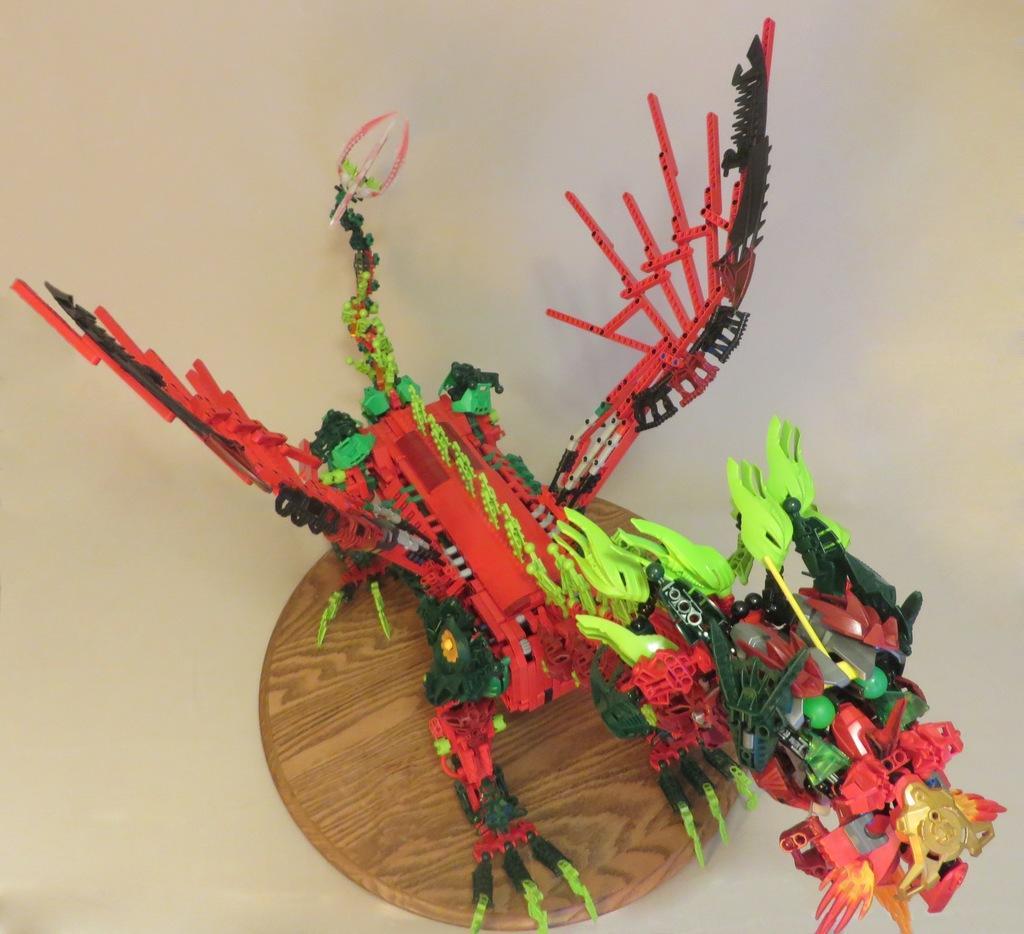Please provide a concise description of this image. On this wooden platter there is a toy. This wooden platter is kept on a white surface. 